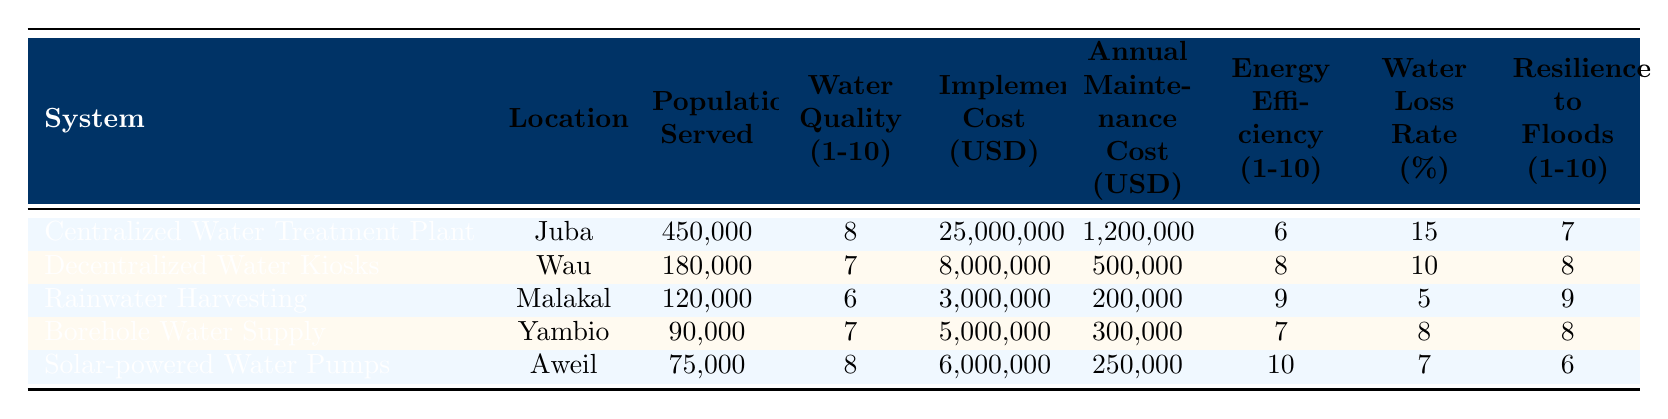What is the population served by the Centralized Water Treatment Plant? The table indicates the population served by the Centralized Water Treatment Plant is specified in the "Population Served" column. Referring to that row, the value is 450,000.
Answer: 450,000 What is the annual maintenance cost of Rainwater Harvesting? The annual maintenance cost for Rainwater Harvesting is found in the table under the "Annual Maintenance Cost (USD)" column. In the corresponding row for that system, it is 200,000.
Answer: 200,000 Which water management system has the highest energy efficiency rating? The energy efficiency ratings are displayed in the "Energy Efficiency (1-10)" column. Upon inspecting the values, Solar-powered Water Pumps have the highest rating of 10.
Answer: Solar-powered Water Pumps Is the water quality for Borehole Water Supply greater than 6? To answer this question, we check the "Water Quality (1-10)" column for Borehole Water Supply. The value is 7, which is indeed greater than 6.
Answer: Yes What is the difference in implementation costs between Centralized Water Treatment Plant and Rainwater Harvesting? The implementation cost for Centralized Water Treatment Plant is 25,000,000 and for Rainwater Harvesting it is 3,000,000. The difference is calculated as 25,000,000 - 3,000,000 = 22,000,000.
Answer: 22,000,000 What is the average water quality rating of all systems in the table? First, sum the water quality ratings: 8 + 7 + 6 + 7 + 8 = 36. There are 5 systems total, so the average is 36 / 5 = 7.2.
Answer: 7.2 Is the resilience to floods for Decentralized Water Kiosks higher than that of Solar-powered Water Pumps? The resilience values found in the "Resilience to Floods (1-10)" column for Decentralized Water Kiosks is 8, while for Solar-powered Water Pumps it is 6. Since 8 is greater than 6, the answer is yes.
Answer: Yes What system has the highest water loss rate, and what is that rate? Looking under the "Water Loss Rate (%)" column, the Centralized Water Treatment Plant shows a water loss rate of 15%, which is higher than the others: 10%, 5%, 8%, and 7%.
Answer: Centralized Water Treatment Plant, 15% How many more people does the Centralized Water Treatment Plant serve compared to the Borehole Water Supply? The Centralized Water Treatment Plant serves 450,000 people, while Borehole Water Supply serves 90,000. The difference is calculated as 450,000 - 90,000 = 360,000.
Answer: 360,000 